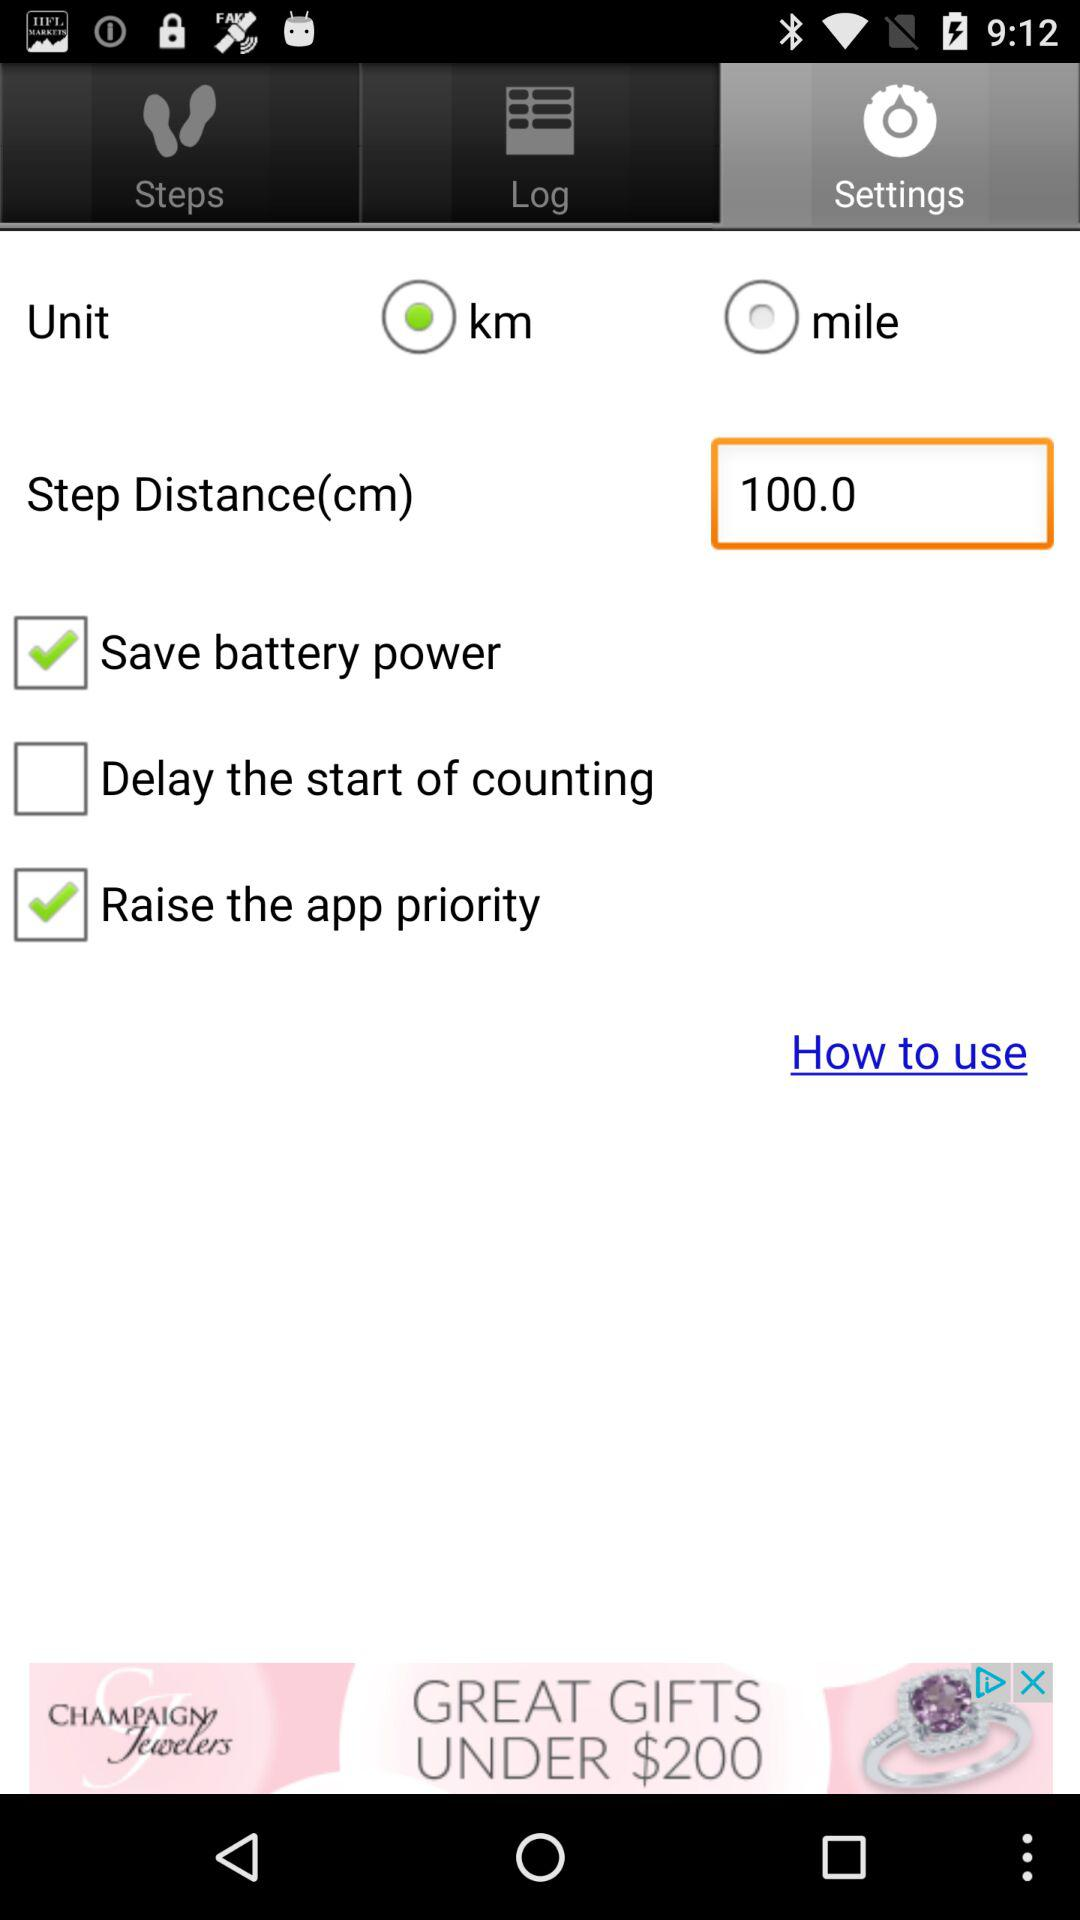What is the status of "Save battery power"? The status is on. 